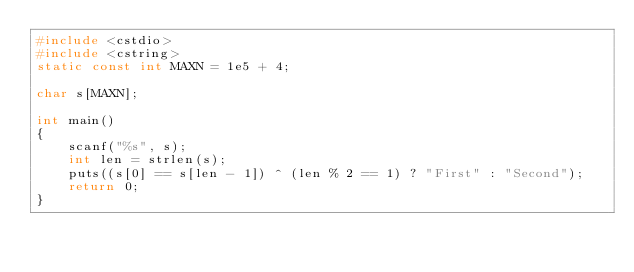<code> <loc_0><loc_0><loc_500><loc_500><_C++_>#include <cstdio>
#include <cstring>
static const int MAXN = 1e5 + 4;

char s[MAXN];

int main()
{
    scanf("%s", s);
    int len = strlen(s);
    puts((s[0] == s[len - 1]) ^ (len % 2 == 1) ? "First" : "Second");
    return 0;
}
</code> 